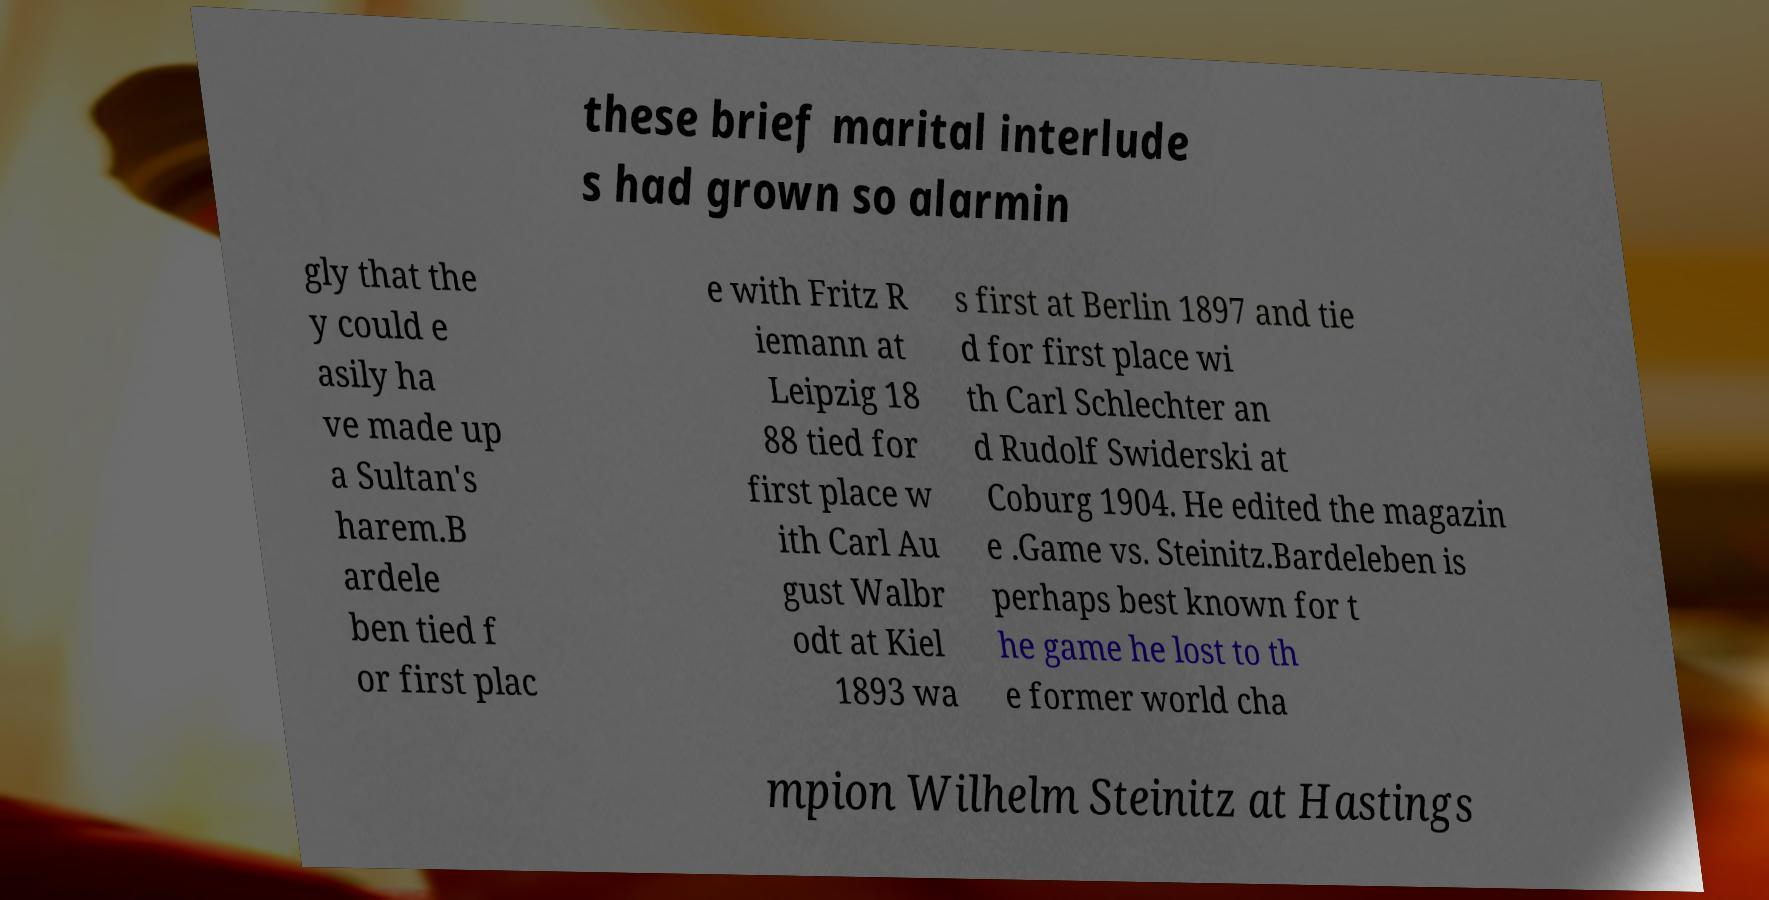Please read and relay the text visible in this image. What does it say? these brief marital interlude s had grown so alarmin gly that the y could e asily ha ve made up a Sultan's harem.B ardele ben tied f or first plac e with Fritz R iemann at Leipzig 18 88 tied for first place w ith Carl Au gust Walbr odt at Kiel 1893 wa s first at Berlin 1897 and tie d for first place wi th Carl Schlechter an d Rudolf Swiderski at Coburg 1904. He edited the magazin e .Game vs. Steinitz.Bardeleben is perhaps best known for t he game he lost to th e former world cha mpion Wilhelm Steinitz at Hastings 